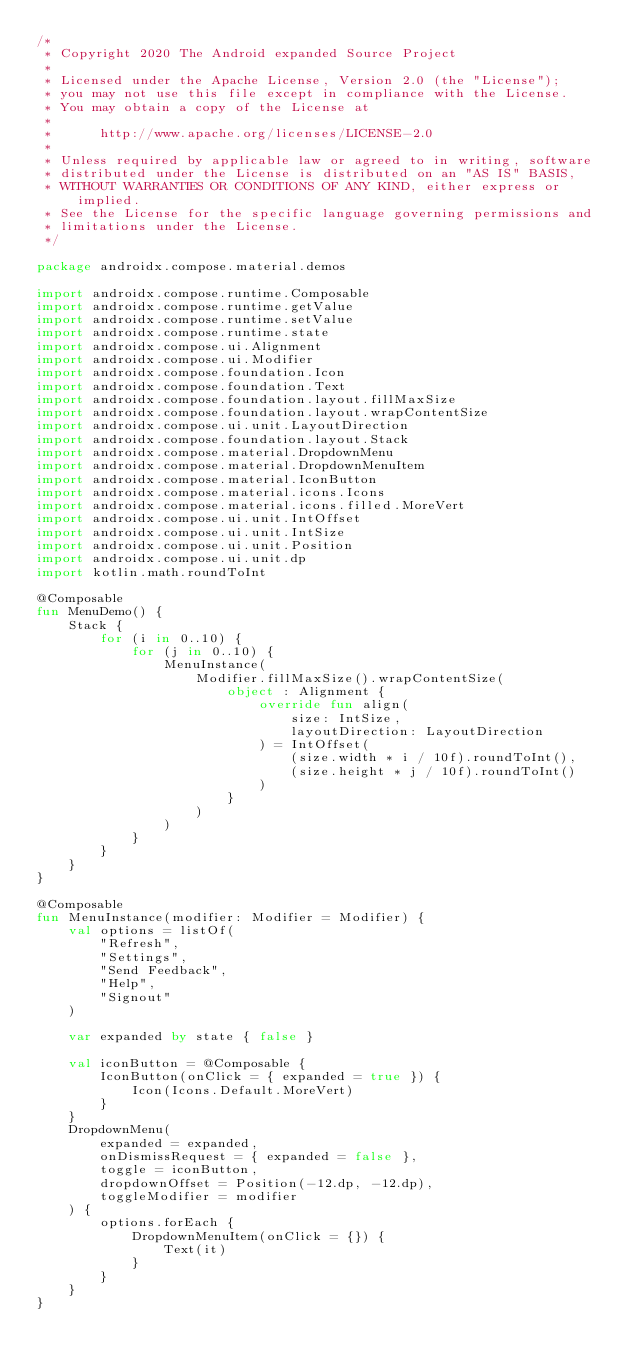Convert code to text. <code><loc_0><loc_0><loc_500><loc_500><_Kotlin_>/*
 * Copyright 2020 The Android expanded Source Project
 *
 * Licensed under the Apache License, Version 2.0 (the "License");
 * you may not use this file except in compliance with the License.
 * You may obtain a copy of the License at
 *
 *      http://www.apache.org/licenses/LICENSE-2.0
 *
 * Unless required by applicable law or agreed to in writing, software
 * distributed under the License is distributed on an "AS IS" BASIS,
 * WITHOUT WARRANTIES OR CONDITIONS OF ANY KIND, either express or implied.
 * See the License for the specific language governing permissions and
 * limitations under the License.
 */

package androidx.compose.material.demos

import androidx.compose.runtime.Composable
import androidx.compose.runtime.getValue
import androidx.compose.runtime.setValue
import androidx.compose.runtime.state
import androidx.compose.ui.Alignment
import androidx.compose.ui.Modifier
import androidx.compose.foundation.Icon
import androidx.compose.foundation.Text
import androidx.compose.foundation.layout.fillMaxSize
import androidx.compose.foundation.layout.wrapContentSize
import androidx.compose.ui.unit.LayoutDirection
import androidx.compose.foundation.layout.Stack
import androidx.compose.material.DropdownMenu
import androidx.compose.material.DropdownMenuItem
import androidx.compose.material.IconButton
import androidx.compose.material.icons.Icons
import androidx.compose.material.icons.filled.MoreVert
import androidx.compose.ui.unit.IntOffset
import androidx.compose.ui.unit.IntSize
import androidx.compose.ui.unit.Position
import androidx.compose.ui.unit.dp
import kotlin.math.roundToInt

@Composable
fun MenuDemo() {
    Stack {
        for (i in 0..10) {
            for (j in 0..10) {
                MenuInstance(
                    Modifier.fillMaxSize().wrapContentSize(
                        object : Alignment {
                            override fun align(
                                size: IntSize,
                                layoutDirection: LayoutDirection
                            ) = IntOffset(
                                (size.width * i / 10f).roundToInt(),
                                (size.height * j / 10f).roundToInt()
                            )
                        }
                    )
                )
            }
        }
    }
}

@Composable
fun MenuInstance(modifier: Modifier = Modifier) {
    val options = listOf(
        "Refresh",
        "Settings",
        "Send Feedback",
        "Help",
        "Signout"
    )

    var expanded by state { false }

    val iconButton = @Composable {
        IconButton(onClick = { expanded = true }) {
            Icon(Icons.Default.MoreVert)
        }
    }
    DropdownMenu(
        expanded = expanded,
        onDismissRequest = { expanded = false },
        toggle = iconButton,
        dropdownOffset = Position(-12.dp, -12.dp),
        toggleModifier = modifier
    ) {
        options.forEach {
            DropdownMenuItem(onClick = {}) {
                Text(it)
            }
        }
    }
}</code> 